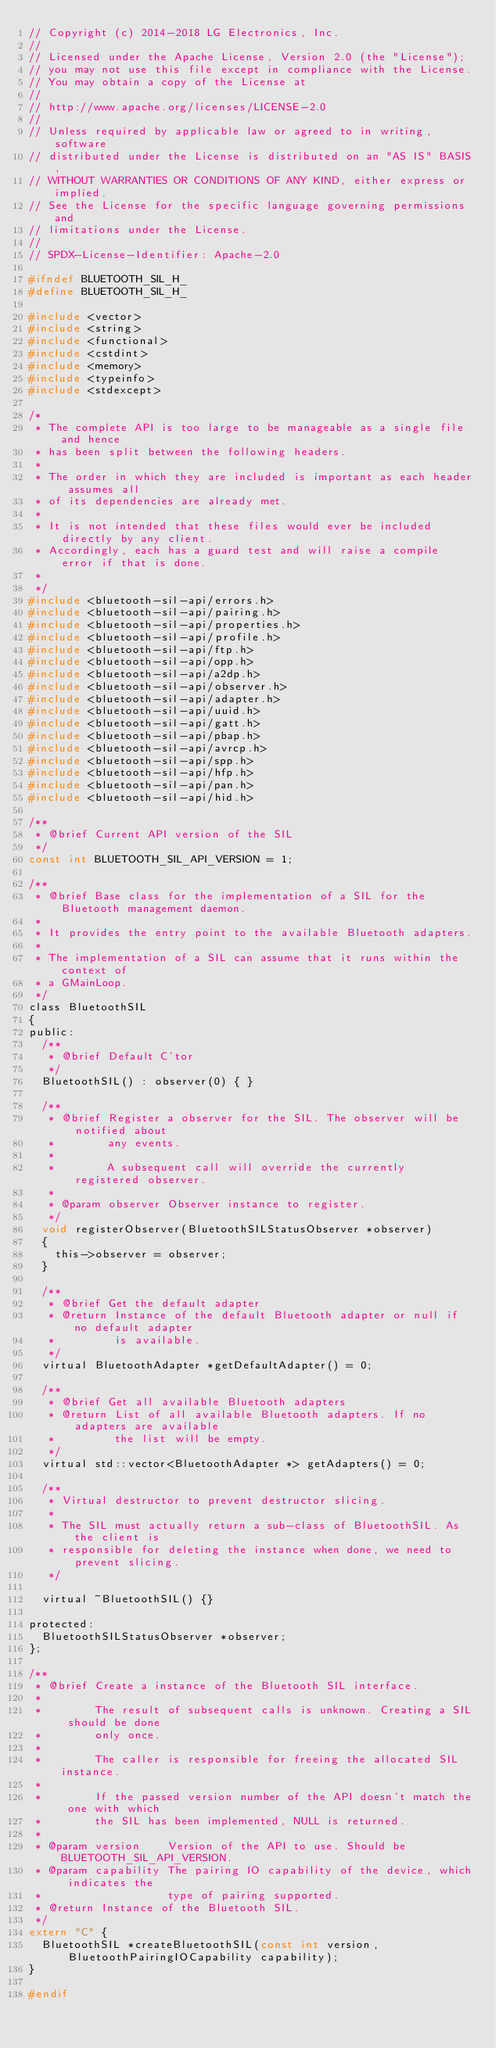Convert code to text. <code><loc_0><loc_0><loc_500><loc_500><_C_>// Copyright (c) 2014-2018 LG Electronics, Inc.
//
// Licensed under the Apache License, Version 2.0 (the "License");
// you may not use this file except in compliance with the License.
// You may obtain a copy of the License at
//
// http://www.apache.org/licenses/LICENSE-2.0
//
// Unless required by applicable law or agreed to in writing, software
// distributed under the License is distributed on an "AS IS" BASIS,
// WITHOUT WARRANTIES OR CONDITIONS OF ANY KIND, either express or implied.
// See the License for the specific language governing permissions and
// limitations under the License.
//
// SPDX-License-Identifier: Apache-2.0

#ifndef BLUETOOTH_SIL_H_
#define BLUETOOTH_SIL_H_

#include <vector>
#include <string>
#include <functional>
#include <cstdint>
#include <memory>
#include <typeinfo>
#include <stdexcept>

/*
 * The complete API is too large to be manageable as a single file and hence
 * has been split between the following headers.
 *
 * The order in which they are included is important as each header assumes all
 * of its dependencies are already met.
 *
 * It is not intended that these files would ever be included directly by any client.
 * Accordingly, each has a guard test and will raise a compile error if that is done.
 *
 */
#include <bluetooth-sil-api/errors.h>
#include <bluetooth-sil-api/pairing.h>
#include <bluetooth-sil-api/properties.h>
#include <bluetooth-sil-api/profile.h>
#include <bluetooth-sil-api/ftp.h>
#include <bluetooth-sil-api/opp.h>
#include <bluetooth-sil-api/a2dp.h>
#include <bluetooth-sil-api/observer.h>
#include <bluetooth-sil-api/adapter.h>
#include <bluetooth-sil-api/uuid.h>
#include <bluetooth-sil-api/gatt.h>
#include <bluetooth-sil-api/pbap.h>
#include <bluetooth-sil-api/avrcp.h>
#include <bluetooth-sil-api/spp.h>
#include <bluetooth-sil-api/hfp.h>
#include <bluetooth-sil-api/pan.h>
#include <bluetooth-sil-api/hid.h>

/**
 * @brief Current API version of the SIL
 */
const int BLUETOOTH_SIL_API_VERSION = 1;

/**
 * @brief Base class for the implementation of a SIL for the Bluetooth management daemon.
 *
 * It provides the entry point to the available Bluetooth adapters.
 *
 * The implementation of a SIL can assume that it runs within the context of
 * a GMainLoop.
 */
class BluetoothSIL
{
public:
	/**
	 * @brief Default C'tor
	 */
	BluetoothSIL() : observer(0) { }

	/**
	 * @brief Register a observer for the SIL. The observer will be notified about
	 *        any events.
	 *
	 *        A subsequent call will override the currently registered observer.
	 *
	 * @param observer Observer instance to register.
	 */
	void registerObserver(BluetoothSILStatusObserver *observer)
	{
		this->observer = observer;
	}

	/**
	 * @brief Get the default adapter
	 * @return Instance of the default Bluetooth adapter or null if no default adapter
	 *         is available.
	 */
	virtual BluetoothAdapter *getDefaultAdapter() = 0;

	/**
	 * @brief Get all available Bluetooth adapters
	 * @return List of all available Bluetooth adapters. If no adapters are available
	 *         the list will be empty.
	 */
	virtual std::vector<BluetoothAdapter *> getAdapters() = 0;

	/**
	 * Virtual destructor to prevent destructor slicing.
	 *
	 * The SIL must actually return a sub-class of BluetoothSIL. As the client is
	 * responsible for deleting the instance when done, we need to prevent slicing.
	 */

	virtual ~BluetoothSIL() {}

protected:
	BluetoothSILStatusObserver *observer;
};

/**
 * @brief Create a instance of the Bluetooth SIL interface.
 *
 *        The result of subsequent calls is unknown. Creating a SIL should be done
 *        only once.
 *
 *        The caller is responsible for freeing the allocated SIL instance.
 *
 *        If the passed version number of the API doesn't match the one with which
 *        the SIL has been implemented, NULL is returned.
 *
 * @param version    Version of the API to use. Should be BLUETOOTH_SIL_API_VERSION.
 * @param capability The pairing IO capability of the device, which indicates the
 *                   type of pairing supported.
 * @return Instance of the Bluetooth SIL.
 */
extern "C" {
	BluetoothSIL *createBluetoothSIL(const int version, BluetoothPairingIOCapability capability);
}

#endif


</code> 